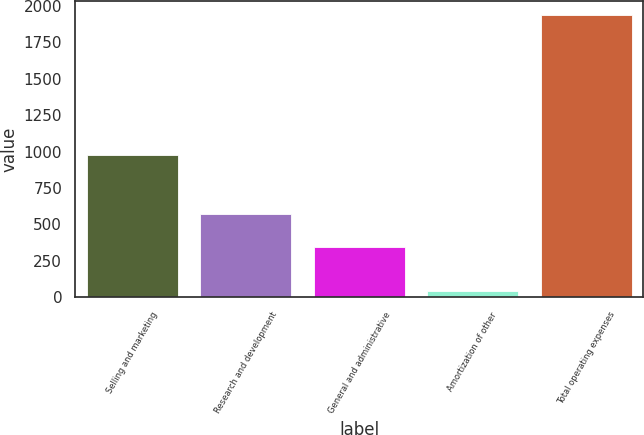Convert chart. <chart><loc_0><loc_0><loc_500><loc_500><bar_chart><fcel>Selling and marketing<fcel>Research and development<fcel>General and administrative<fcel>Amortization of other<fcel>Total operating expenses<nl><fcel>976<fcel>573<fcel>348<fcel>42<fcel>1939<nl></chart> 